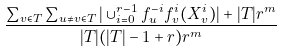<formula> <loc_0><loc_0><loc_500><loc_500>\frac { \sum _ { v \in T } \sum _ { u \neq v \in T } | \cup _ { i = 0 } ^ { r - 1 } f _ { u } ^ { - i } f _ { v } ^ { i } ( X _ { v } ^ { i } ) | + | T | r ^ { m } } { | T | ( | T | - 1 + r ) r ^ { m } }</formula> 